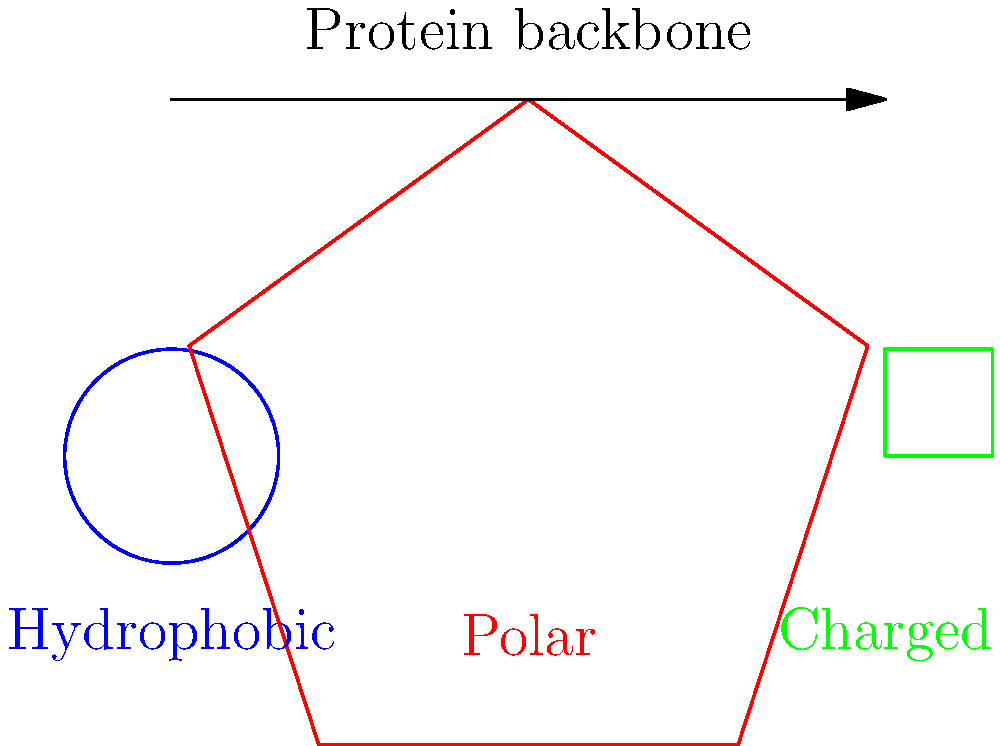In protein folding, the geometric properties of amino acid side chains play a crucial role. Based on the diagram, which type of side chain is most likely to be found in the hydrophobic core of a globular protein, and how does this contribute to the overall stability of the protein structure? To answer this question, we need to consider the properties of different amino acid side chains and their impact on protein folding:

1. Hydrophobic side chains (blue circle):
   - These are non-polar and tend to avoid water.
   - In an aqueous environment, they cluster together to minimize contact with water.

2. Polar side chains (red pentagon):
   - These can form hydrogen bonds with water and other polar molecules.
   - They are usually found on the protein's surface or in regions that interact with water.

3. Charged side chains (green square):
   - These have a strong affinity for water and other charged molecules.
   - They are typically located on the protein's surface or in regions involved in electrostatic interactions.

4. Protein folding principles:
   - Globular proteins fold to minimize their free energy.
   - The hydrophobic effect is a major driving force in protein folding.

5. Hydrophobic core formation:
   - Hydrophobic side chains tend to cluster in the protein's interior, forming a hydrophobic core.
   - This arrangement minimizes contact between hydrophobic groups and water, reducing the overall free energy of the system.

6. Stability contribution:
   - The hydrophobic core provides stability to the protein structure by:
     a) Minimizing unfavorable interactions between non-polar groups and water.
     b) Creating van der Waals interactions between closely packed hydrophobic side chains.
     c) Reducing the entropy of the surrounding water molecules.

Therefore, the hydrophobic side chains (blue circle) are most likely to be found in the hydrophobic core of a globular protein. Their clustering contributes significantly to the overall stability of the protein structure by driving the folding process and maintaining the compact, folded state.
Answer: Hydrophobic side chains; they form a stabilizing core by minimizing contact with water and maximizing van der Waals interactions. 